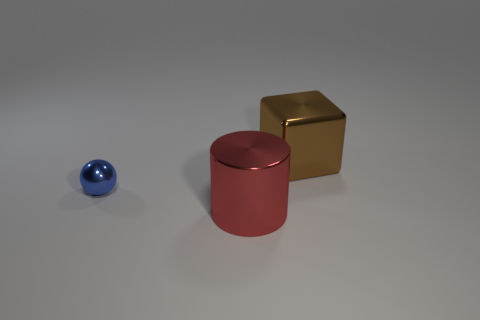Is there a small sphere that has the same color as the big shiny cylinder?
Your answer should be very brief. No. What number of small blue balls are there?
Keep it short and to the point. 1. There is a large thing in front of the big thing that is to the right of the metallic object that is in front of the tiny metallic object; what is it made of?
Make the answer very short. Metal. Is there a brown thing that has the same material as the big red cylinder?
Make the answer very short. Yes. Are the blue sphere and the cube made of the same material?
Your answer should be compact. Yes. How many cylinders are brown things or tiny things?
Your answer should be very brief. 0. The large cylinder that is made of the same material as the tiny thing is what color?
Ensure brevity in your answer.  Red. Are there fewer blue cylinders than tiny metal things?
Offer a very short reply. Yes. Does the big thing to the left of the brown thing have the same shape as the large shiny thing that is behind the large red cylinder?
Provide a succinct answer. No. What number of things are large cubes or small cyan things?
Ensure brevity in your answer.  1. 